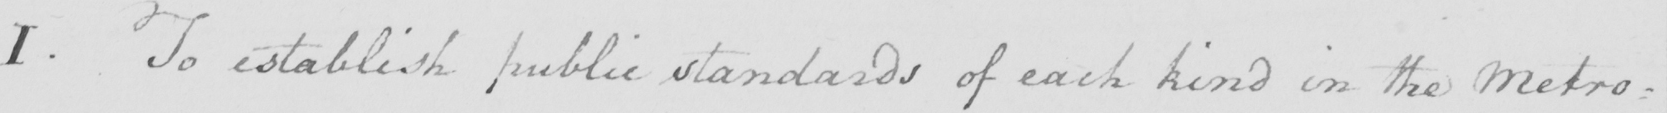Can you tell me what this handwritten text says? I. To establish public standards of each kind in the Metro: 